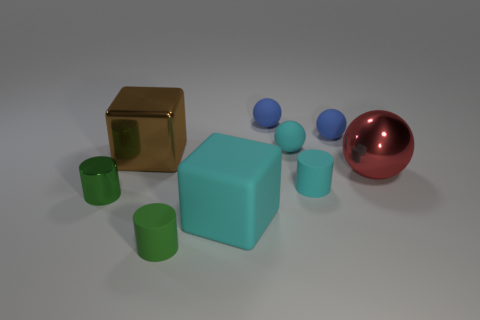What shape is the brown object that is the same size as the cyan block?
Provide a short and direct response. Cube. There is a matte ball that is on the right side of the cyan matte cylinder; does it have the same size as the large rubber cube?
Give a very brief answer. No. What material is the red object that is the same size as the brown metal block?
Provide a short and direct response. Metal. There is a large cyan block in front of the small green cylinder that is on the left side of the big brown metallic cube; are there any metal balls left of it?
Your response must be concise. No. Is there any other thing that has the same shape as the small metallic object?
Offer a very short reply. Yes. There is a large block behind the large ball; is it the same color as the big shiny object right of the brown metal object?
Keep it short and to the point. No. Is there a big cylinder?
Your response must be concise. No. What material is the other small thing that is the same color as the tiny shiny thing?
Provide a succinct answer. Rubber. There is a matte thing to the left of the large block that is in front of the big shiny object that is left of the large cyan cube; what is its size?
Offer a very short reply. Small. Is the shape of the green matte thing the same as the cyan object behind the brown thing?
Give a very brief answer. No. 